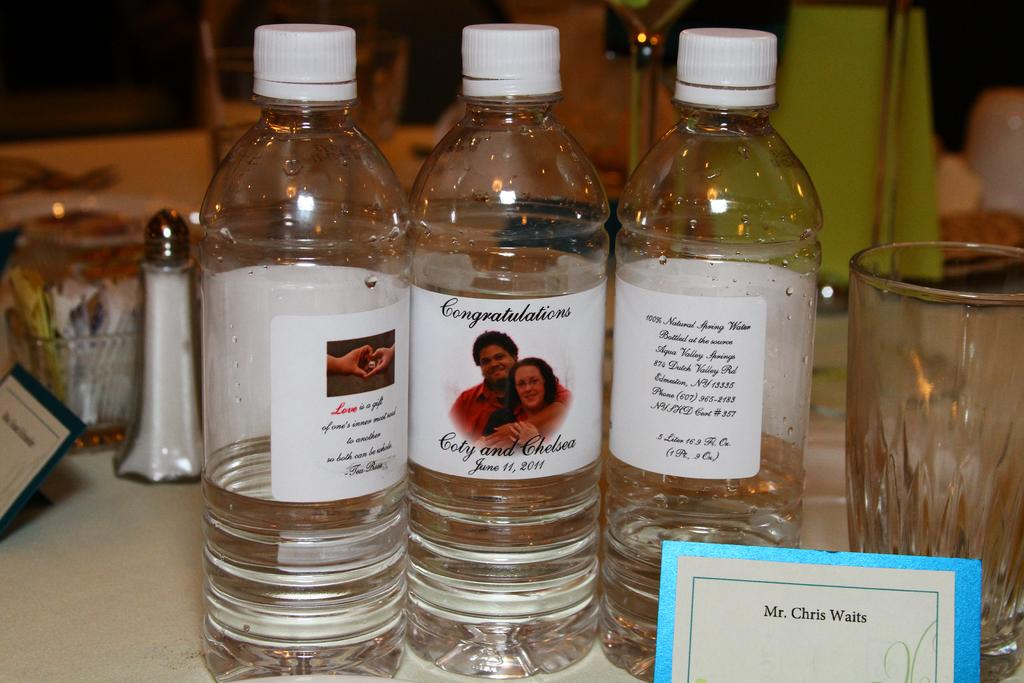<image>
Describe the image concisely. Personalized bottles of water congratulate Coty and Chelsea on their wedding 